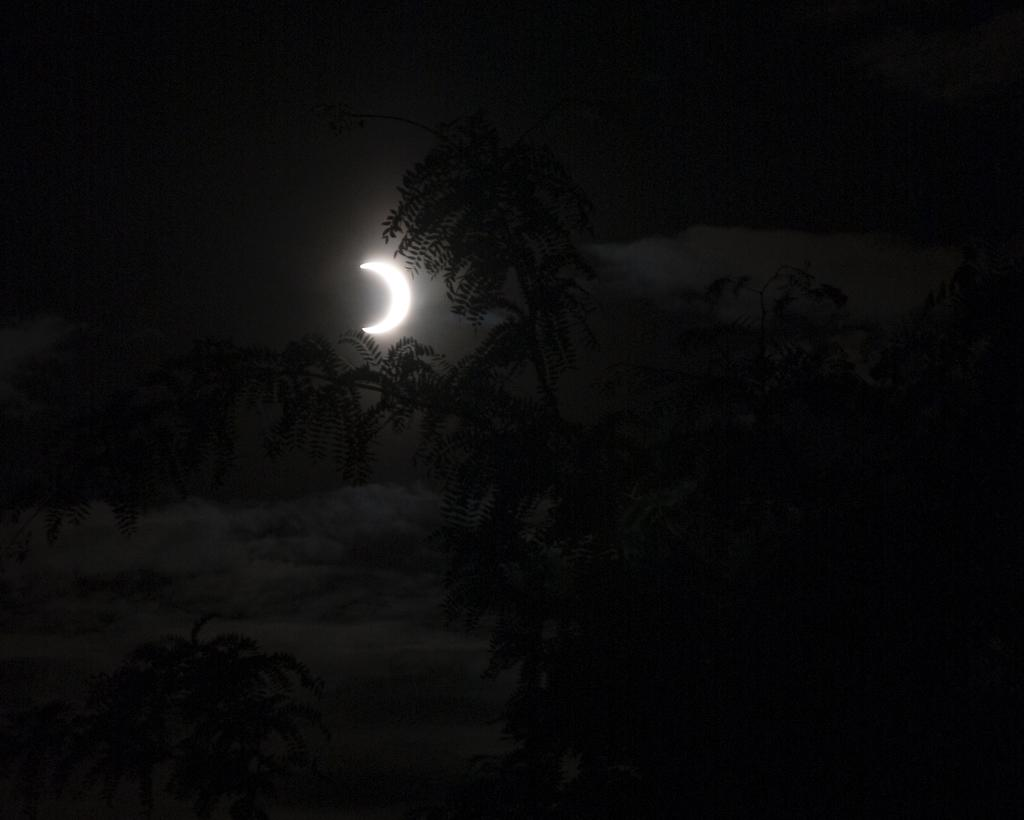What type of vegetation is present in the image? There are trees with branches and leaves in the image. What celestial body can be seen in the sky? There is a moon visible in the sky. What else can be seen in the sky besides the moon? There are clouds in the sky. What type of apple is being held by the governor in the image? There is no governor or apple present in the image. 